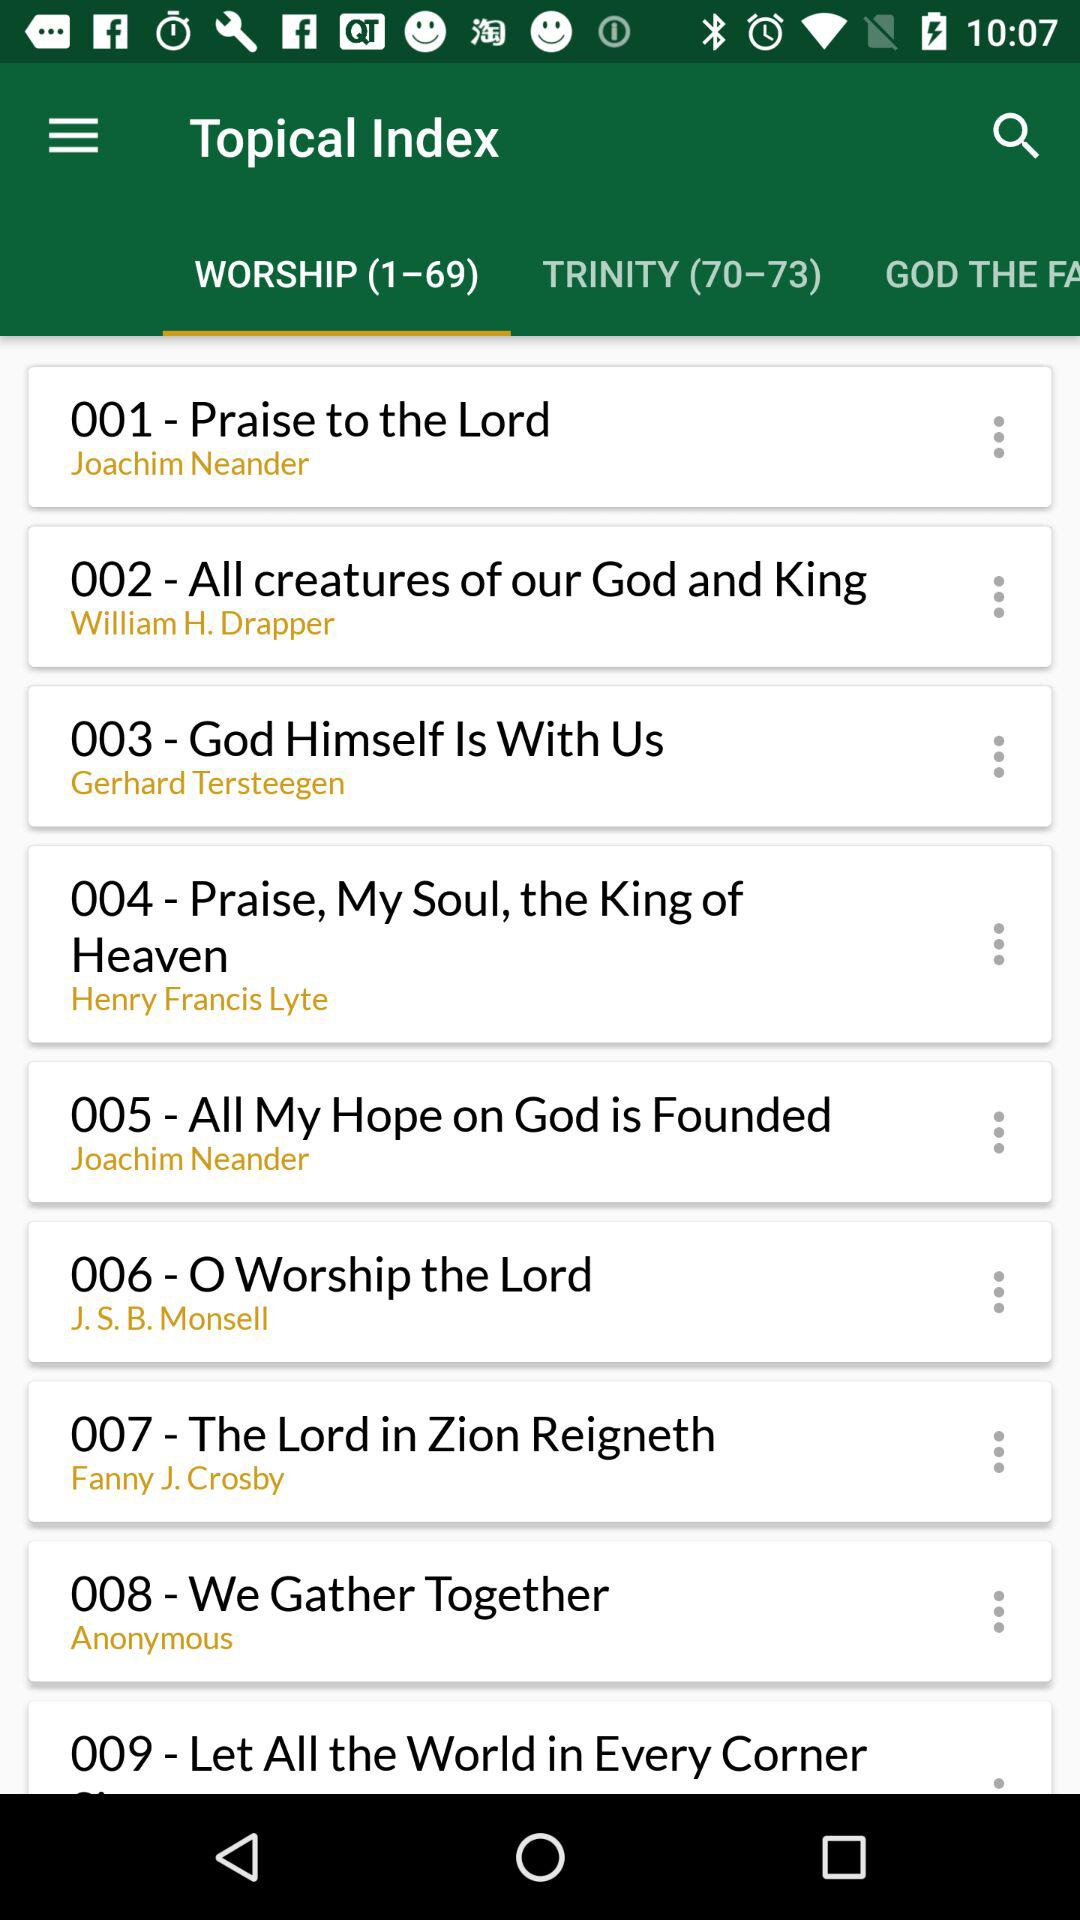How many songs in total are there? There are 69 songs in total. 